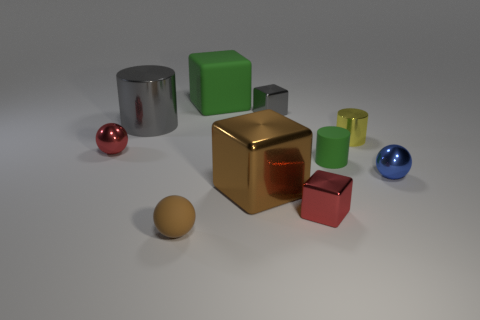What time of day does the lighting in this scene suggest? The soft shadows and gentle light diffusion hint at an interior scene, likely illuminated by artificial light, rather than a specific time of day. 